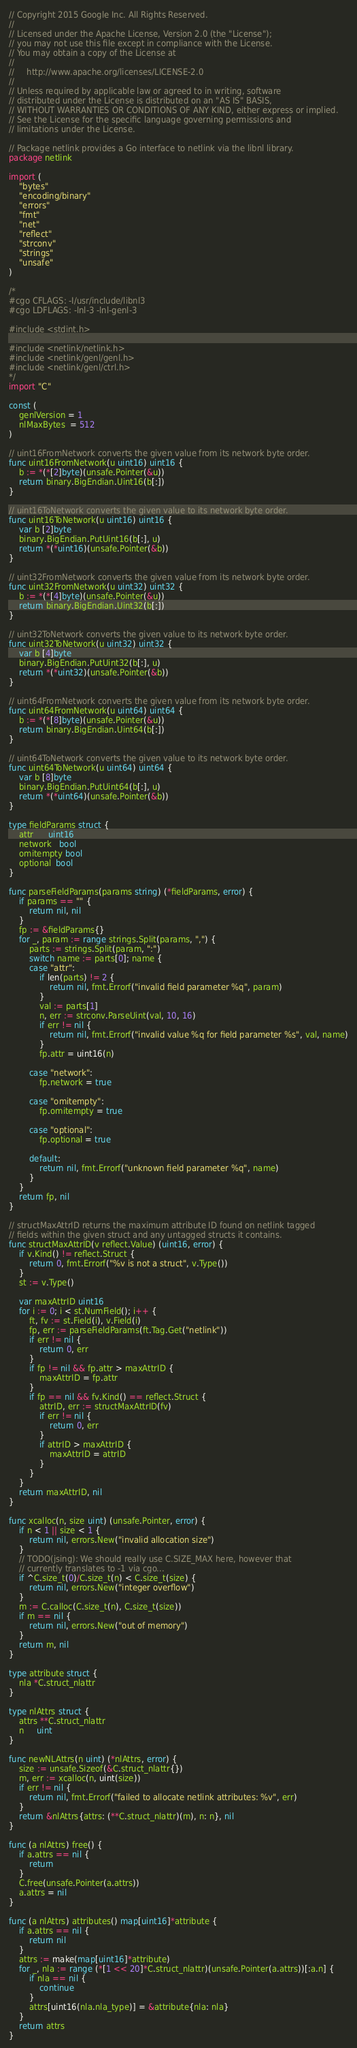Convert code to text. <code><loc_0><loc_0><loc_500><loc_500><_Go_>// Copyright 2015 Google Inc. All Rights Reserved.
//
// Licensed under the Apache License, Version 2.0 (the "License");
// you may not use this file except in compliance with the License.
// You may obtain a copy of the License at
//
//     http://www.apache.org/licenses/LICENSE-2.0
//
// Unless required by applicable law or agreed to in writing, software
// distributed under the License is distributed on an "AS IS" BASIS,
// WITHOUT WARRANTIES OR CONDITIONS OF ANY KIND, either express or implied.
// See the License for the specific language governing permissions and
// limitations under the License.

// Package netlink provides a Go interface to netlink via the libnl library.
package netlink

import (
	"bytes"
	"encoding/binary"
	"errors"
	"fmt"
	"net"
	"reflect"
	"strconv"
	"strings"
	"unsafe"
)

/*
#cgo CFLAGS: -I/usr/include/libnl3
#cgo LDFLAGS: -lnl-3 -lnl-genl-3

#include <stdint.h>

#include <netlink/netlink.h>
#include <netlink/genl/genl.h>
#include <netlink/genl/ctrl.h>
*/
import "C"

const (
	genlVersion = 1
	nlMaxBytes  = 512
)

// uint16FromNetwork converts the given value from its network byte order.
func uint16FromNetwork(u uint16) uint16 {
	b := *(*[2]byte)(unsafe.Pointer(&u))
	return binary.BigEndian.Uint16(b[:])
}

// uint16ToNetwork converts the given value to its network byte order.
func uint16ToNetwork(u uint16) uint16 {
	var b [2]byte
	binary.BigEndian.PutUint16(b[:], u)
	return *(*uint16)(unsafe.Pointer(&b))
}

// uint32FromNetwork converts the given value from its network byte order.
func uint32FromNetwork(u uint32) uint32 {
	b := *(*[4]byte)(unsafe.Pointer(&u))
	return binary.BigEndian.Uint32(b[:])
}

// uint32ToNetwork converts the given value to its network byte order.
func uint32ToNetwork(u uint32) uint32 {
	var b [4]byte
	binary.BigEndian.PutUint32(b[:], u)
	return *(*uint32)(unsafe.Pointer(&b))
}

// uint64FromNetwork converts the given value from its network byte order.
func uint64FromNetwork(u uint64) uint64 {
	b := *(*[8]byte)(unsafe.Pointer(&u))
	return binary.BigEndian.Uint64(b[:])
}

// uint64ToNetwork converts the given value to its network byte order.
func uint64ToNetwork(u uint64) uint64 {
	var b [8]byte
	binary.BigEndian.PutUint64(b[:], u)
	return *(*uint64)(unsafe.Pointer(&b))
}

type fieldParams struct {
	attr      uint16
	network   bool
	omitempty bool
	optional  bool
}

func parseFieldParams(params string) (*fieldParams, error) {
	if params == "" {
		return nil, nil
	}
	fp := &fieldParams{}
	for _, param := range strings.Split(params, ",") {
		parts := strings.Split(param, ":")
		switch name := parts[0]; name {
		case "attr":
			if len(parts) != 2 {
				return nil, fmt.Errorf("invalid field parameter %q", param)
			}
			val := parts[1]
			n, err := strconv.ParseUint(val, 10, 16)
			if err != nil {
				return nil, fmt.Errorf("invalid value %q for field parameter %s", val, name)
			}
			fp.attr = uint16(n)

		case "network":
			fp.network = true

		case "omitempty":
			fp.omitempty = true

		case "optional":
			fp.optional = true

		default:
			return nil, fmt.Errorf("unknown field parameter %q", name)
		}
	}
	return fp, nil
}

// structMaxAttrID returns the maximum attribute ID found on netlink tagged
// fields within the given struct and any untagged structs it contains.
func structMaxAttrID(v reflect.Value) (uint16, error) {
	if v.Kind() != reflect.Struct {
		return 0, fmt.Errorf("%v is not a struct", v.Type())
	}
	st := v.Type()

	var maxAttrID uint16
	for i := 0; i < st.NumField(); i++ {
		ft, fv := st.Field(i), v.Field(i)
		fp, err := parseFieldParams(ft.Tag.Get("netlink"))
		if err != nil {
			return 0, err
		}
		if fp != nil && fp.attr > maxAttrID {
			maxAttrID = fp.attr
		}
		if fp == nil && fv.Kind() == reflect.Struct {
			attrID, err := structMaxAttrID(fv)
			if err != nil {
				return 0, err
			}
			if attrID > maxAttrID {
				maxAttrID = attrID
			}
		}
	}
	return maxAttrID, nil
}

func xcalloc(n, size uint) (unsafe.Pointer, error) {
	if n < 1 || size < 1 {
		return nil, errors.New("invalid allocation size")
	}
	// TODO(jsing): We should really use C.SIZE_MAX here, however that
	// currently translates to -1 via cgo...
	if ^C.size_t(0)/C.size_t(n) < C.size_t(size) {
		return nil, errors.New("integer overflow")
	}
	m := C.calloc(C.size_t(n), C.size_t(size))
	if m == nil {
		return nil, errors.New("out of memory")
	}
	return m, nil
}

type attribute struct {
	nla *C.struct_nlattr
}

type nlAttrs struct {
	attrs **C.struct_nlattr
	n     uint
}

func newNLAttrs(n uint) (*nlAttrs, error) {
	size := unsafe.Sizeof(&C.struct_nlattr{})
	m, err := xcalloc(n, uint(size))
	if err != nil {
		return nil, fmt.Errorf("failed to allocate netlink attributes: %v", err)
	}
	return &nlAttrs{attrs: (**C.struct_nlattr)(m), n: n}, nil
}

func (a nlAttrs) free() {
	if a.attrs == nil {
		return
	}
	C.free(unsafe.Pointer(a.attrs))
	a.attrs = nil
}

func (a nlAttrs) attributes() map[uint16]*attribute {
	if a.attrs == nil {
		return nil
	}
	attrs := make(map[uint16]*attribute)
	for _, nla := range (*[1 << 20]*C.struct_nlattr)(unsafe.Pointer(a.attrs))[:a.n] {
		if nla == nil {
			continue
		}
		attrs[uint16(nla.nla_type)] = &attribute{nla: nla}
	}
	return attrs
}
</code> 